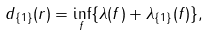Convert formula to latex. <formula><loc_0><loc_0><loc_500><loc_500>d _ { \{ 1 \} } ( r ) & = \inf _ { f } \{ \lambda ( f ) + \lambda _ { \{ 1 \} } ( f ) \} ,</formula> 